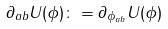Convert formula to latex. <formula><loc_0><loc_0><loc_500><loc_500>\partial _ { a b } U ( \phi ) \colon = \partial _ { \phi _ { a b } } U ( \phi )</formula> 